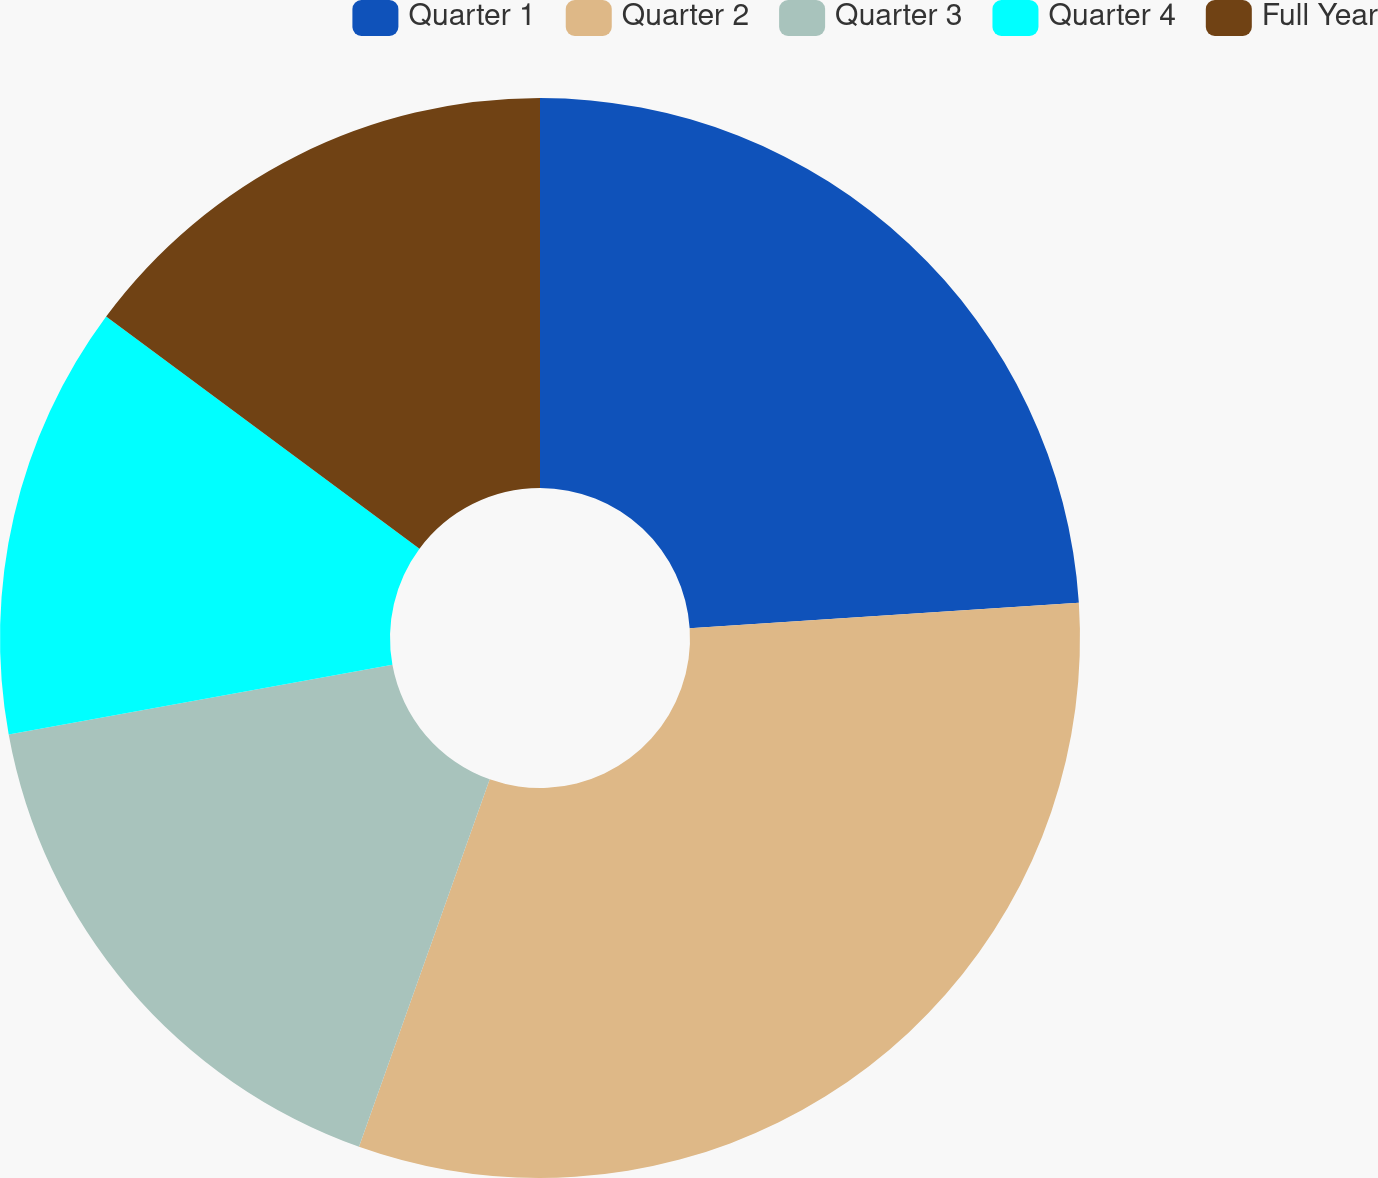Convert chart. <chart><loc_0><loc_0><loc_500><loc_500><pie_chart><fcel>Quarter 1<fcel>Quarter 2<fcel>Quarter 3<fcel>Quarter 4<fcel>Full Year<nl><fcel>23.96%<fcel>31.48%<fcel>16.7%<fcel>13.01%<fcel>14.85%<nl></chart> 